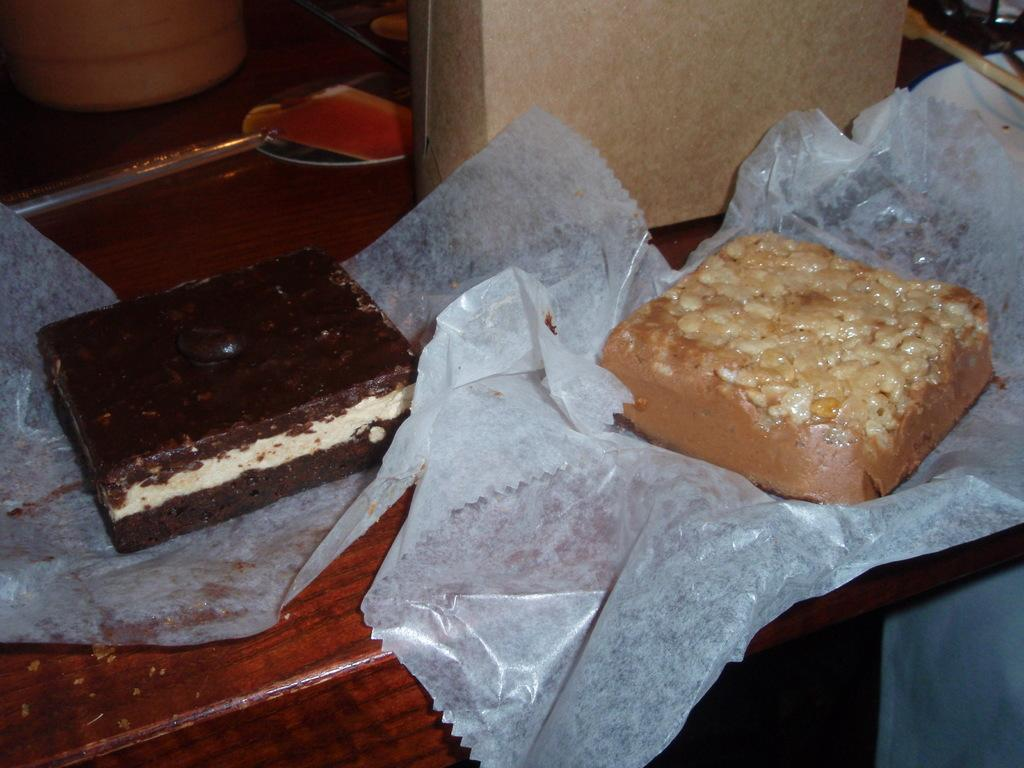What type of items can be seen in the image? There are food items in the image. How are the food items presented? The food items are on papers. What is another object visible in the image? There is a plate in the image. What else can be seen on the table in the image? There are other objects on the table. How does the wealth of the person in the image affect the food items? There is no indication of a person's wealth in the image, nor is there any information about how wealth might affect the food items. 